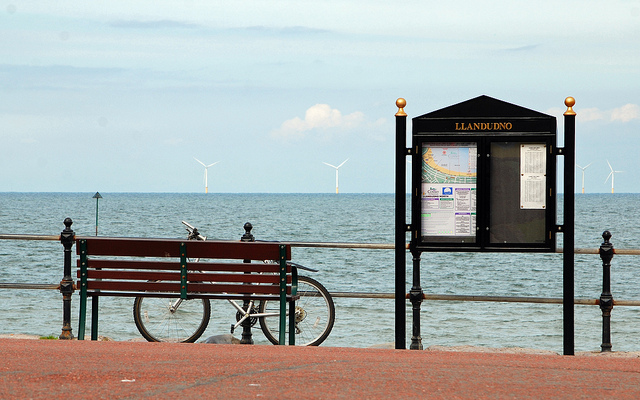Please identify all text content in this image. LLANDUDNO 